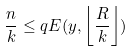<formula> <loc_0><loc_0><loc_500><loc_500>\frac { n } { k } \leq q E ( y , \left \lfloor \frac { R } { k } \right \rfloor )</formula> 